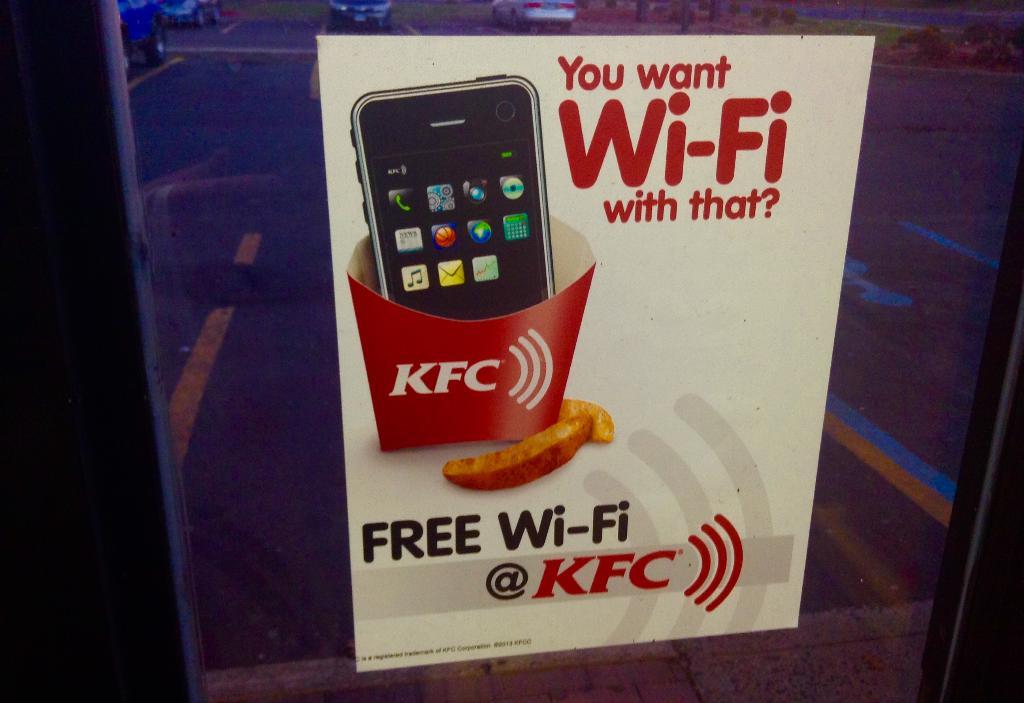What is free at this restaurant?
Ensure brevity in your answer.  Wi-fi. What is kfc offering for free?
Offer a terse response. Wi-fi. 